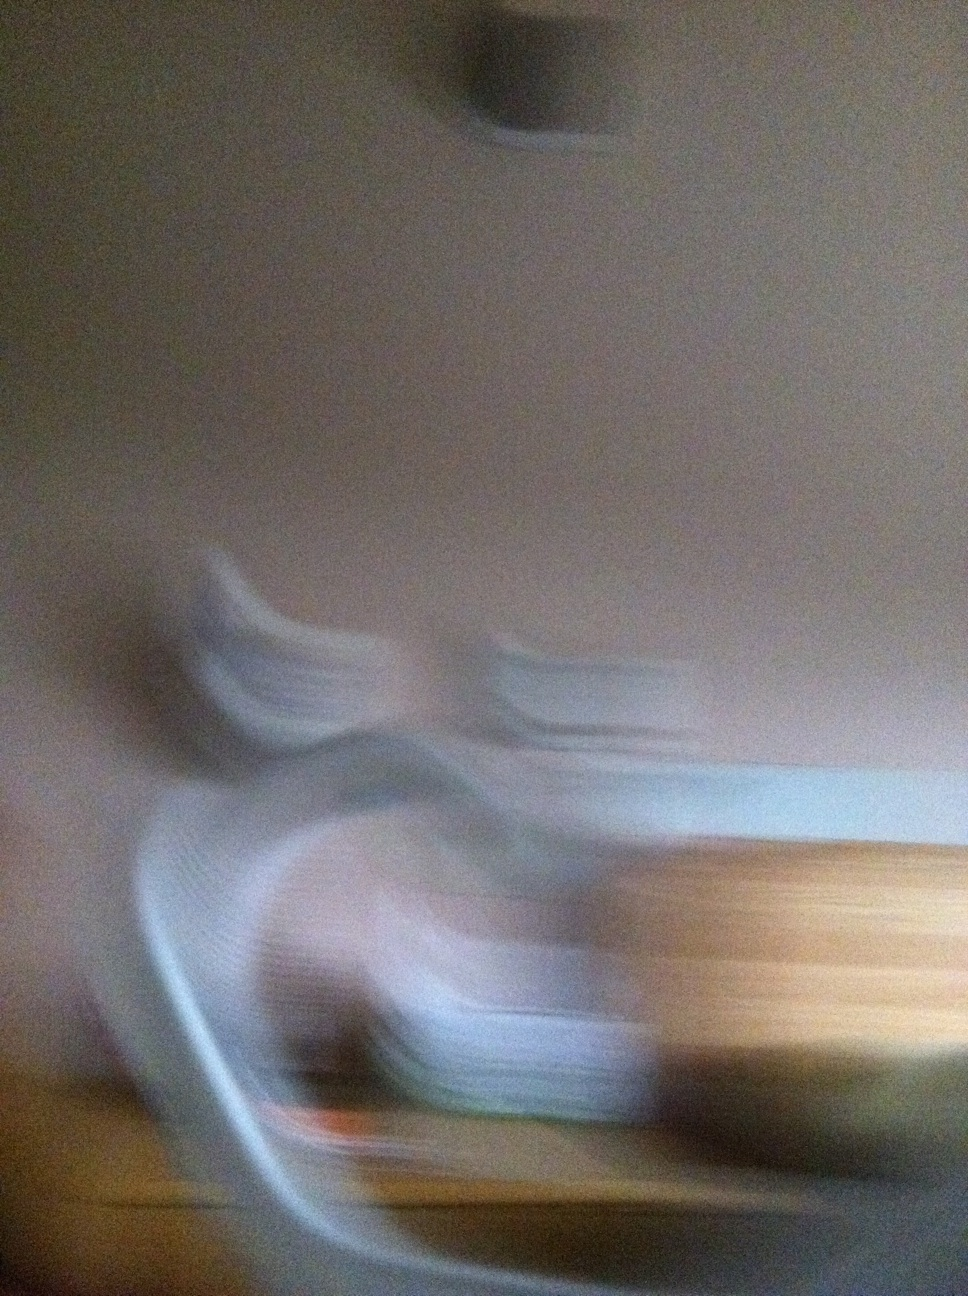Can you create a detailed story based on this image? Once upon a time, in a hidden realm blurred from human sight, there was a dimension called Velloria. Velloria existed in the space between moments, a world where time danced in spirals rather than straight lines. It was a realm where the inhabitants, known as the Vellorians, lived in harmony with nature, technology, and magic. They resided in floating islands that drifted through a sky filled with vibrant colors and swirling energies. Each island was unique; some were covered in lush forests, others had crystalline cities that shimmered in the perpetual twilight. The Vellorians had a deep connection to their world, drawing power from the auroras that painted the sky. However, Velloria's existence was threatened by the Great Blur, a phenomenon that slowly spread, blurring the boundaries of their world. The Vellorians embarked on a quest to find the source of the Blur, venturing into unknown territories, facing challenges, forging alliances, and unlocking ancient secrets. They discovered that the Blur was both a curse and a gift—masking their world from external threats while urging them to evolve and find balance. Through their journey, they learned to harness the Blur, using its power to create new realities, and in doing so, they ensured Velloria thrived for eons. 